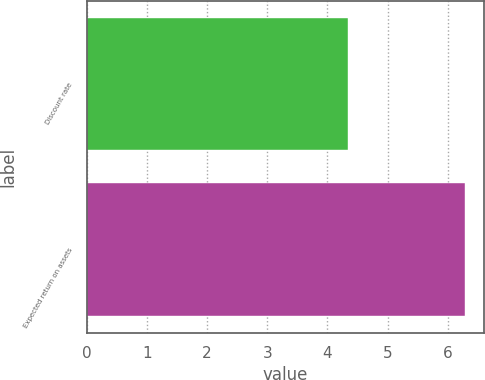Convert chart. <chart><loc_0><loc_0><loc_500><loc_500><bar_chart><fcel>Discount rate<fcel>Expected return on assets<nl><fcel>4.35<fcel>6.29<nl></chart> 